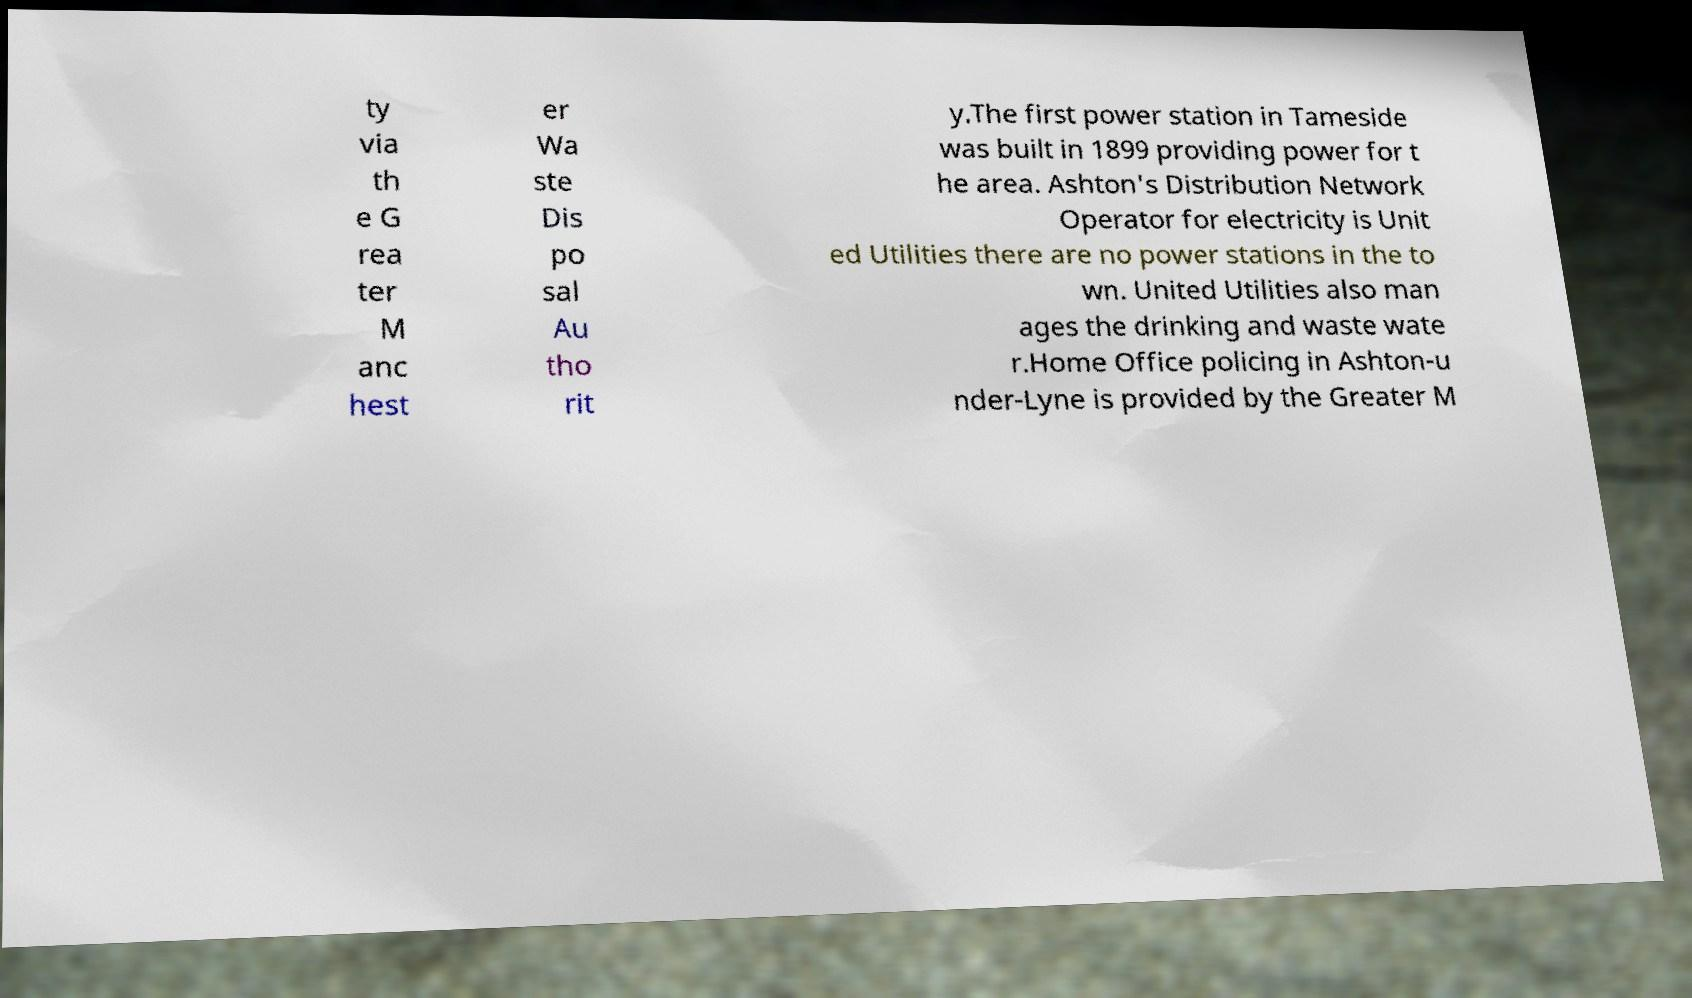For documentation purposes, I need the text within this image transcribed. Could you provide that? ty via th e G rea ter M anc hest er Wa ste Dis po sal Au tho rit y.The first power station in Tameside was built in 1899 providing power for t he area. Ashton's Distribution Network Operator for electricity is Unit ed Utilities there are no power stations in the to wn. United Utilities also man ages the drinking and waste wate r.Home Office policing in Ashton-u nder-Lyne is provided by the Greater M 